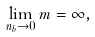Convert formula to latex. <formula><loc_0><loc_0><loc_500><loc_500>\lim _ { n _ { b } \rightarrow 0 } m = \infty ,</formula> 